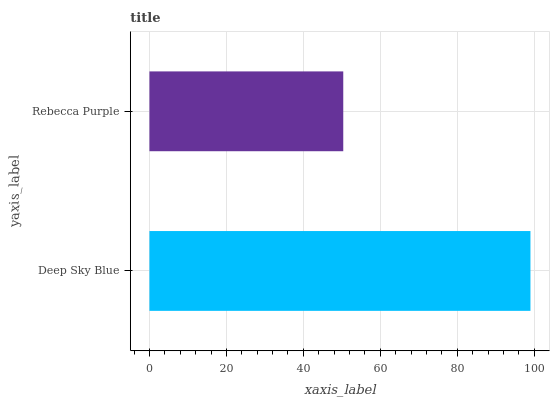Is Rebecca Purple the minimum?
Answer yes or no. Yes. Is Deep Sky Blue the maximum?
Answer yes or no. Yes. Is Rebecca Purple the maximum?
Answer yes or no. No. Is Deep Sky Blue greater than Rebecca Purple?
Answer yes or no. Yes. Is Rebecca Purple less than Deep Sky Blue?
Answer yes or no. Yes. Is Rebecca Purple greater than Deep Sky Blue?
Answer yes or no. No. Is Deep Sky Blue less than Rebecca Purple?
Answer yes or no. No. Is Deep Sky Blue the high median?
Answer yes or no. Yes. Is Rebecca Purple the low median?
Answer yes or no. Yes. Is Rebecca Purple the high median?
Answer yes or no. No. Is Deep Sky Blue the low median?
Answer yes or no. No. 